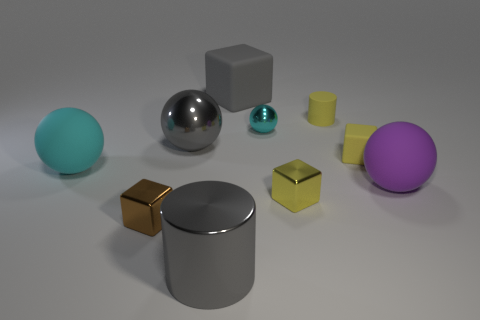Subtract all balls. How many objects are left? 6 Subtract all large purple rubber things. Subtract all gray matte objects. How many objects are left? 8 Add 5 big metallic cylinders. How many big metallic cylinders are left? 6 Add 8 big gray metallic things. How many big gray metallic things exist? 10 Subtract 0 green blocks. How many objects are left? 10 